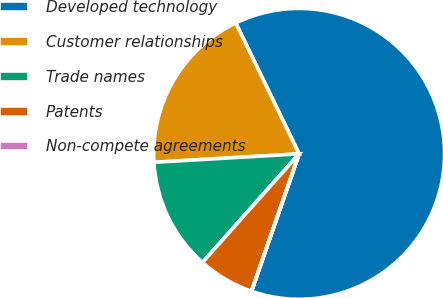<chart> <loc_0><loc_0><loc_500><loc_500><pie_chart><fcel>Developed technology<fcel>Customer relationships<fcel>Trade names<fcel>Patents<fcel>Non-compete agreements<nl><fcel>62.48%<fcel>18.75%<fcel>12.5%<fcel>6.26%<fcel>0.01%<nl></chart> 